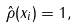Convert formula to latex. <formula><loc_0><loc_0><loc_500><loc_500>\hat { \rho } ( x _ { i } ) = 1 ,</formula> 